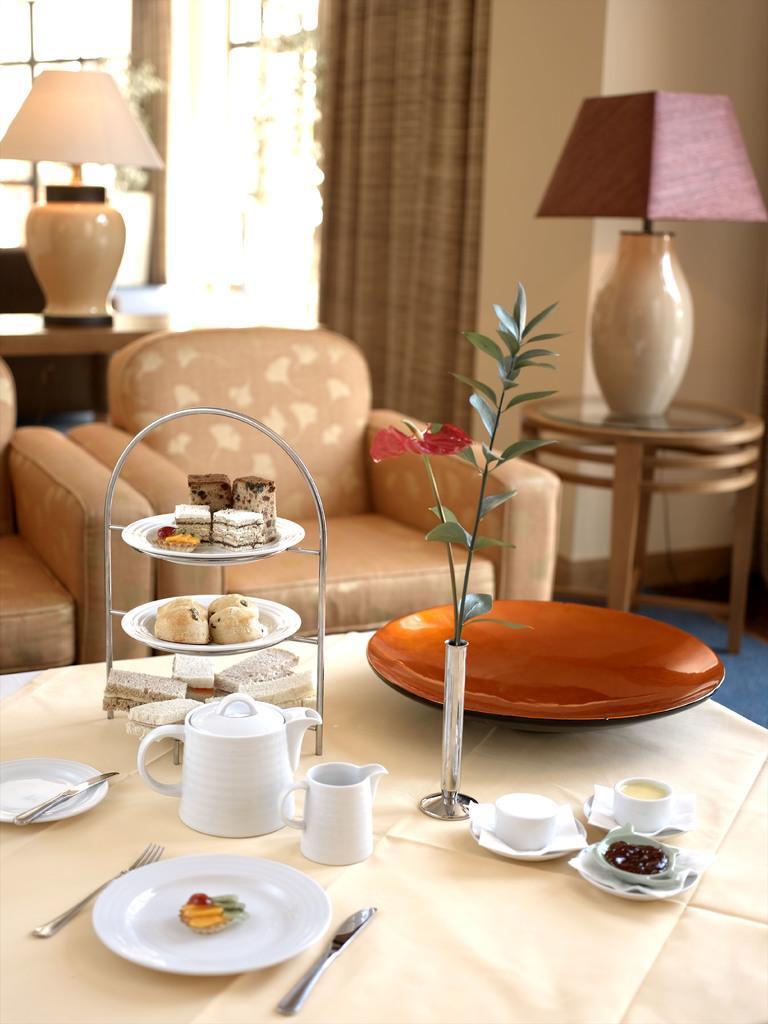Please provide a concise description of this image. In this image there is a table covered with a white colour cloth on this table there is a white colour plate with some food on it, a fork,a knife,white colour cup, white colour jar and a food which is kept on a stand on this table flower vase. In the back there is a sofa and in the background of the sofa we can see a lamp and a curtain with a wall. 